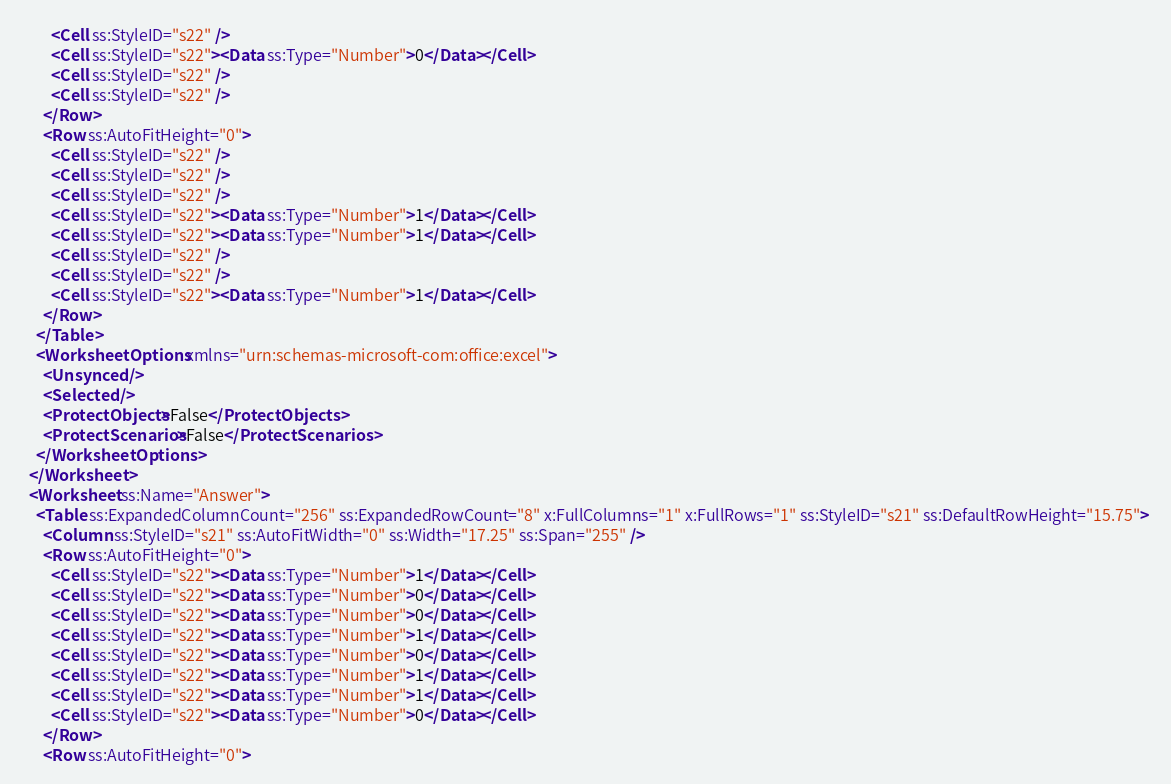<code> <loc_0><loc_0><loc_500><loc_500><_XML_>        <Cell ss:StyleID="s22" />
        <Cell ss:StyleID="s22"><Data ss:Type="Number">0</Data></Cell>
        <Cell ss:StyleID="s22" />
        <Cell ss:StyleID="s22" />
      </Row>
      <Row ss:AutoFitHeight="0">
        <Cell ss:StyleID="s22" />
        <Cell ss:StyleID="s22" />
        <Cell ss:StyleID="s22" />
        <Cell ss:StyleID="s22"><Data ss:Type="Number">1</Data></Cell>
        <Cell ss:StyleID="s22"><Data ss:Type="Number">1</Data></Cell>
        <Cell ss:StyleID="s22" />
        <Cell ss:StyleID="s22" />
        <Cell ss:StyleID="s22"><Data ss:Type="Number">1</Data></Cell>
      </Row>
    </Table>
    <WorksheetOptions xmlns="urn:schemas-microsoft-com:office:excel">
      <Unsynced />
      <Selected />
      <ProtectObjects>False</ProtectObjects>
      <ProtectScenarios>False</ProtectScenarios>
    </WorksheetOptions>
  </Worksheet>
  <Worksheet ss:Name="Answer">
    <Table ss:ExpandedColumnCount="256" ss:ExpandedRowCount="8" x:FullColumns="1" x:FullRows="1" ss:StyleID="s21" ss:DefaultRowHeight="15.75">
      <Column ss:StyleID="s21" ss:AutoFitWidth="0" ss:Width="17.25" ss:Span="255" />
      <Row ss:AutoFitHeight="0">
        <Cell ss:StyleID="s22"><Data ss:Type="Number">1</Data></Cell>
        <Cell ss:StyleID="s22"><Data ss:Type="Number">0</Data></Cell>
        <Cell ss:StyleID="s22"><Data ss:Type="Number">0</Data></Cell>
        <Cell ss:StyleID="s22"><Data ss:Type="Number">1</Data></Cell>
        <Cell ss:StyleID="s22"><Data ss:Type="Number">0</Data></Cell>
        <Cell ss:StyleID="s22"><Data ss:Type="Number">1</Data></Cell>
        <Cell ss:StyleID="s22"><Data ss:Type="Number">1</Data></Cell>
        <Cell ss:StyleID="s22"><Data ss:Type="Number">0</Data></Cell>
      </Row>
      <Row ss:AutoFitHeight="0"></code> 